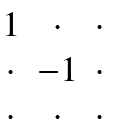<formula> <loc_0><loc_0><loc_500><loc_500>\begin{matrix} 1 & \cdot & \cdot \\ \cdot & - 1 & \cdot \\ \cdot & \cdot & \cdot \end{matrix}</formula> 